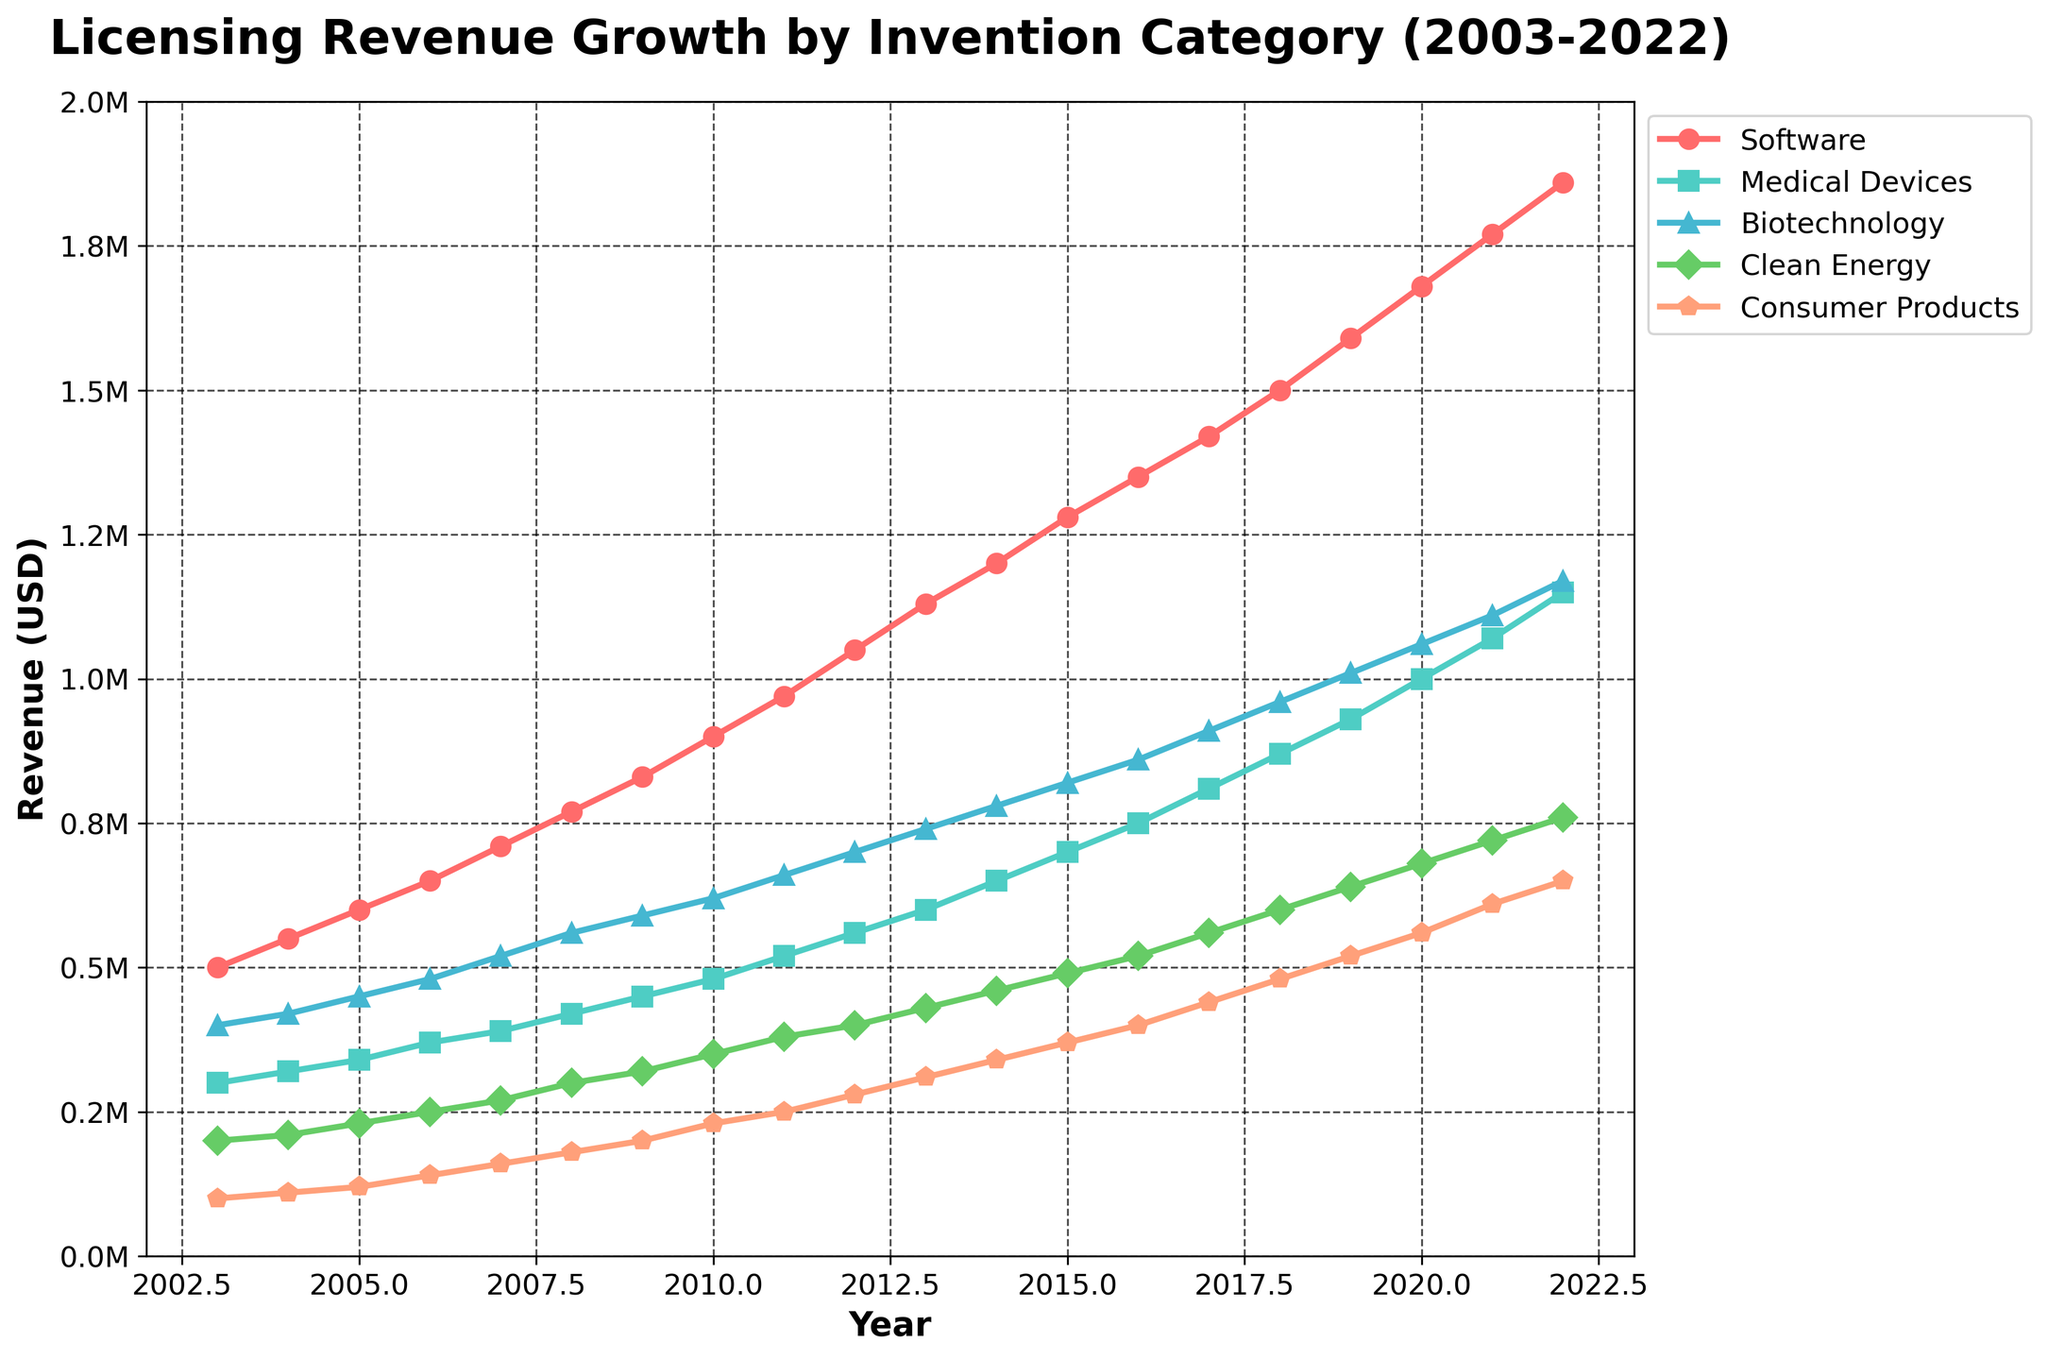Which category showed the highest revenue in 2022? Look at the year 2022 on the x-axis and find the highest point among all the categories on the y-axis.
Answer: Software What was the revenue for Clean Energy in 2016? Follow the line for Clean Energy (green line) to the year 2016 on the x-axis, then read the corresponding value on the y-axis.
Answer: 520,000 USD Which two categories had the closest revenue values in 2012? Compare the y-axis values for all categories in the year 2012 and identify the two lines with the smallest difference.
Answer: Medical Devices and Biotechnology By how much did the revenue for Biotechnology grow from 2003 to 2022? Identify the revenue for Biotechnology in 2003 and 2022 on the y-axis, then subtract the 2003 value from the 2022 value.
Answer: 770,000 USD Which category had the smallest increase in revenue from 2003 to 2022? Calculate the difference between the revenue values in 2003 and 2022 for all categories and determine which is the smallest.
Answer: Consumer Products How did the average yearly growth rate of Software compare to that of Clean Energy? Calculate the difference in revenue for Software and Clean Energy between 2003 and 2022, then divide by the number of years (2022-2003) to find the average annual growth rate and compare.
Answer: Software had a higher average yearly growth rate In which year did Medical Devices first surpass 1,000,000 USD in revenue? Follow the Medical Devices line (blue line) and find the first year where the y-value exceeds 1,000,000 USD.
Answer: 2020 On average, how much did the revenue for Consumer Products increase each year? Calculate the total increase in revenue for Consumer Products from 2003 to 2022, then divide by the number of years (2022-2003).
Answer: 28,947 USD per year Which category had the most consistent revenue growth over the 20 years? Compare the lines for each category and determine which one shows a relatively steady and linear increase without sharp fluctuations.
Answer: Software What was the combined revenue for all categories in 2015? Sum the y-values for all categories in the year 2015.
Answer: 3,200,000 USD 